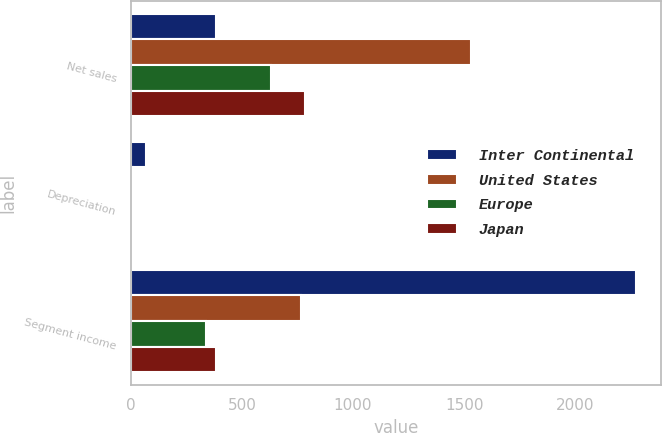<chart> <loc_0><loc_0><loc_500><loc_500><stacked_bar_chart><ecel><fcel>Net sales<fcel>Depreciation<fcel>Segment income<nl><fcel>Inter Continental<fcel>382<fcel>70<fcel>2273<nl><fcel>United States<fcel>1529<fcel>12<fcel>767<nl><fcel>Europe<fcel>630<fcel>4<fcel>337<nl><fcel>Japan<fcel>783<fcel>6<fcel>382<nl></chart> 